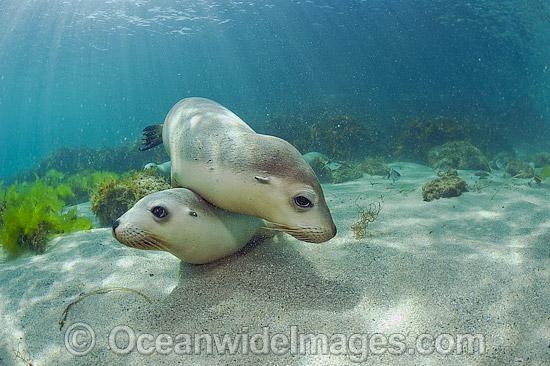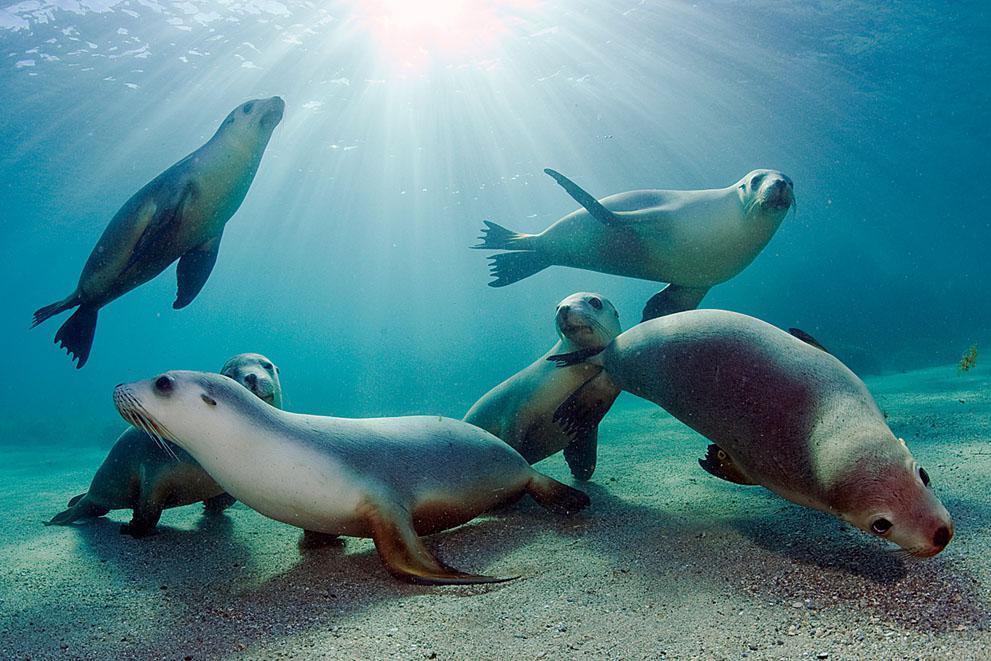The first image is the image on the left, the second image is the image on the right. For the images shown, is this caption "None of the images have more than two seals." true? Answer yes or no. No. The first image is the image on the left, the second image is the image on the right. Examine the images to the left and right. Is the description "In the left image there is one seal on top of another seal." accurate? Answer yes or no. Yes. 